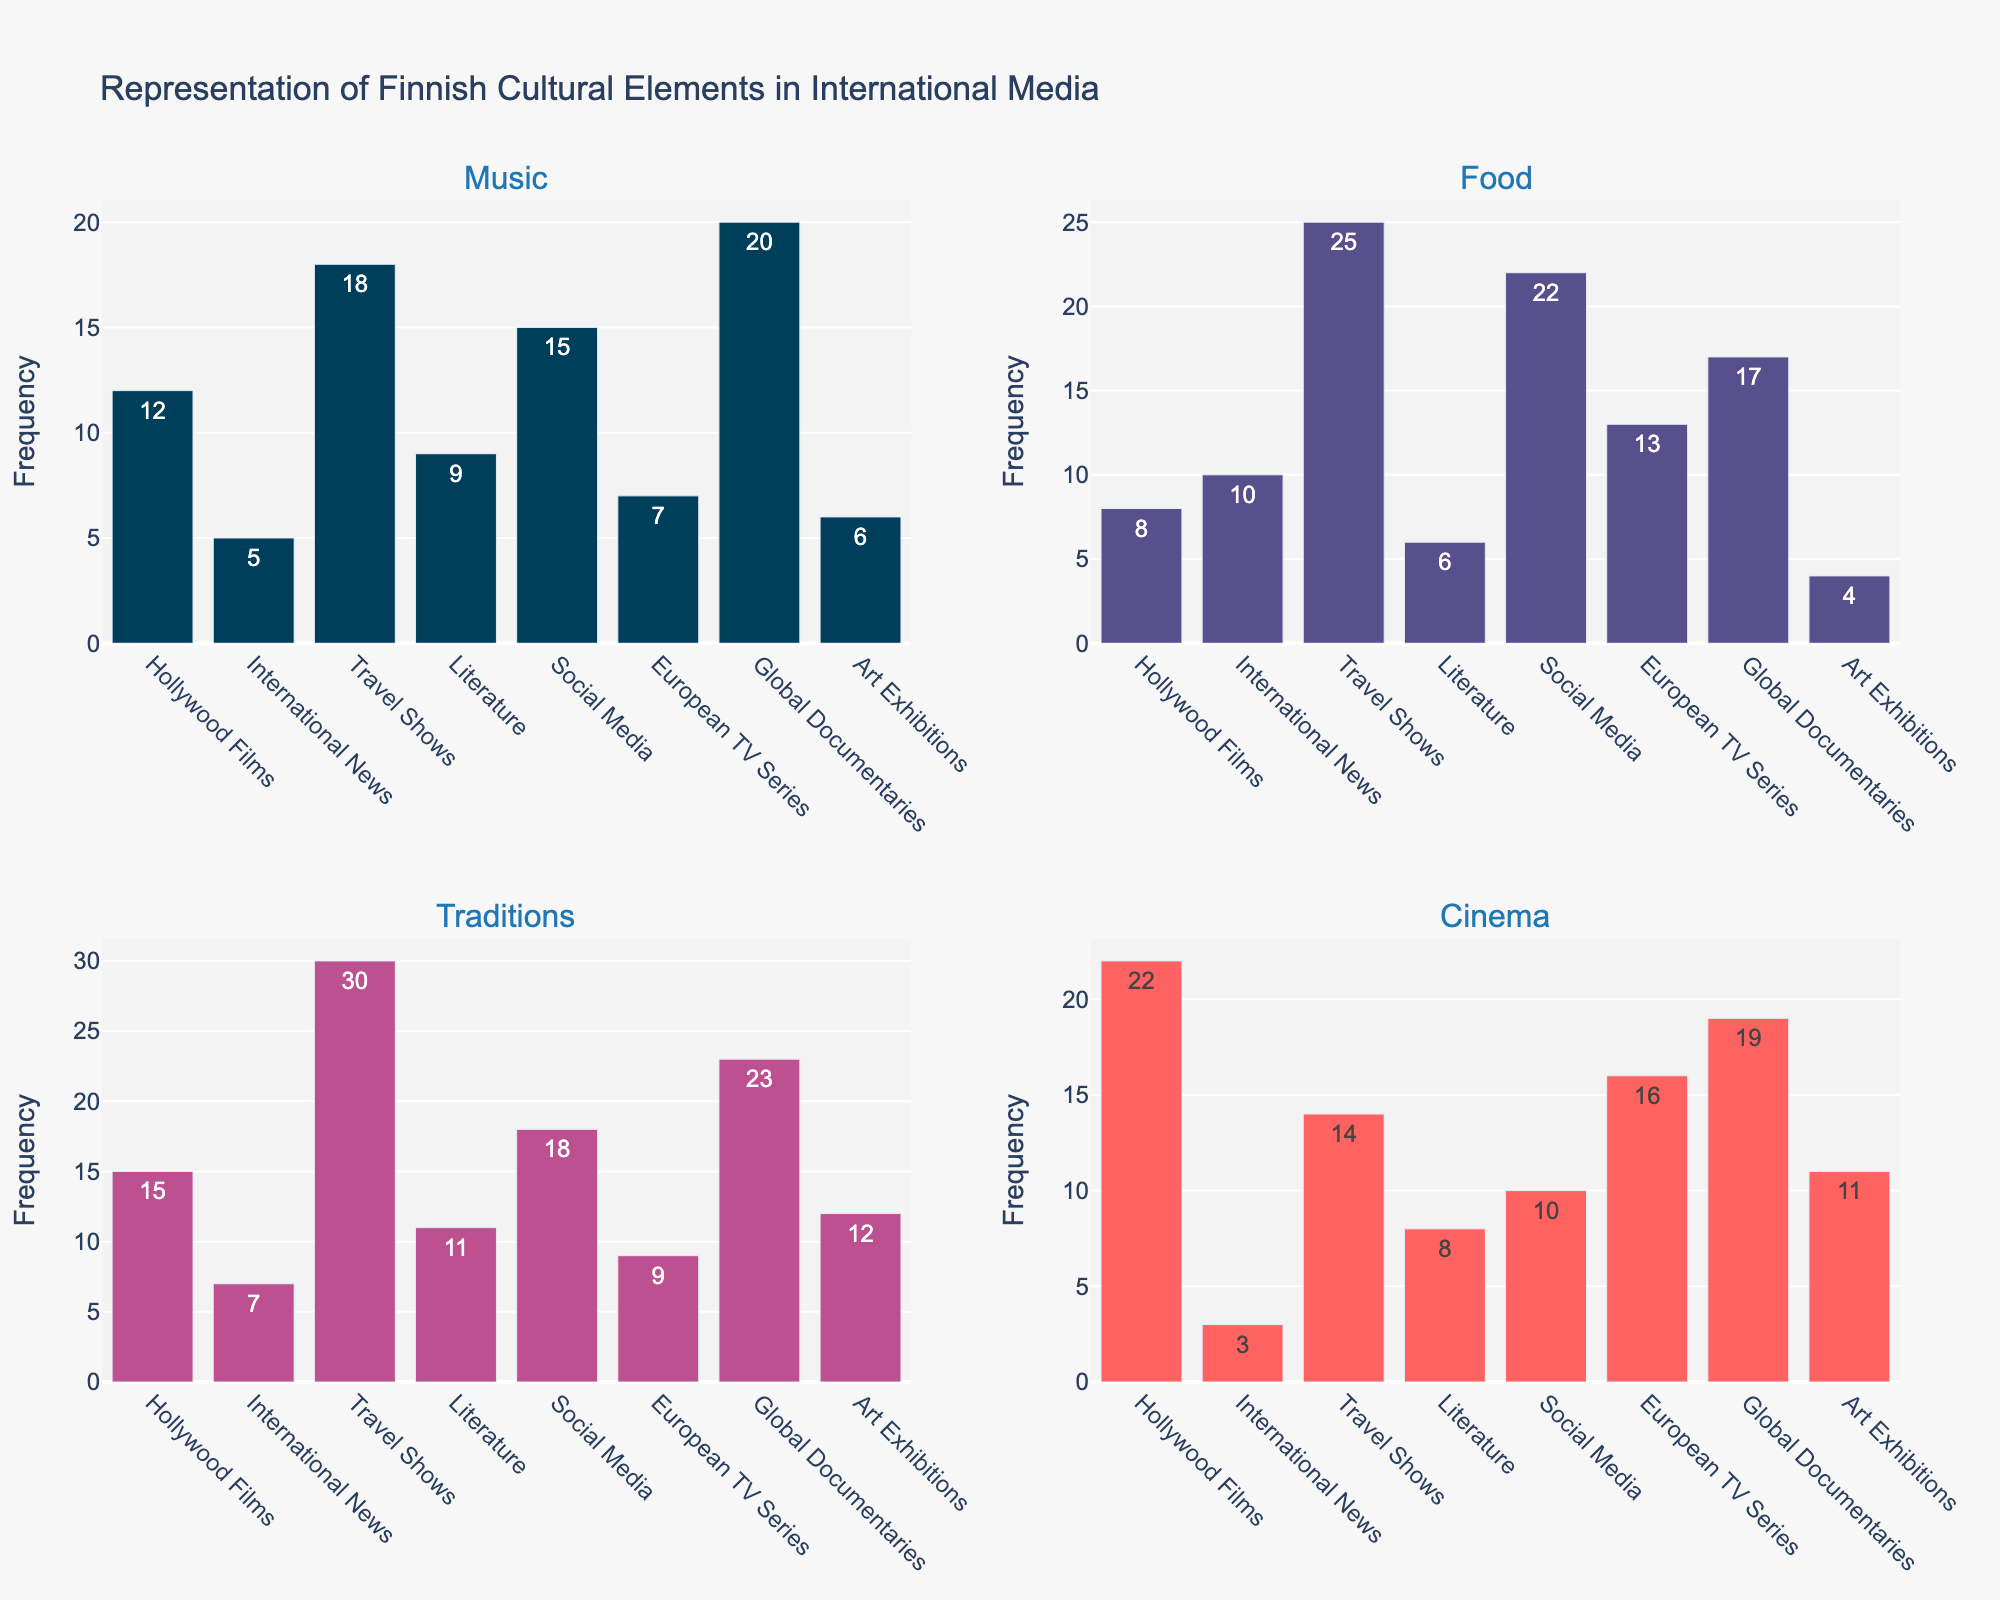What is the total number of representations of Finnish food in international media? Sum the values for Finnish food across all the subplots. (8+10+25+6+22+13+17+4) = 105
Answer: 105 Which category represents Finnish traditions the most? Identify the bar with the highest value in the "Traditions" subplot. The highest value is 30 in Travel Shows.
Answer: Travel Shows In the 'Music' subplot, which category has the lowest representation? Identify the bar with the lowest value in the "Music" subplot. The lowest value is 5 in International News.
Answer: International News How many more representations of Finnish music are in Global Documentaries compared to Hollywood Films? Subtract the number in Hollywood Films from the number in Global Documentaries for the "Music" category. 20 - 12 = 8
Answer: 8 What is the average representation of Finnish cinema across all categories? Sum the values for Finnish cinema and divide by the number of categories. (22+3+14+8+10+16+19+11)/8 = 103/8 = 12.875
Answer: 12.875 Which subplot has the most balanced representation across all categories, meaning the smallest range between the highest and lowest values? Calculate the range (max - min) for each subplot and identify the smallest range. Food: 25-4=21, Music: 20-5=15, Traditions: 30-9=21, Cinema: 22-3=19. Music has the smallest range of 15.
Answer: Music How many representations of Finnish traditions are found in Art Exhibitions and Social Media combined? Sum the values for Finnish traditions in Art Exhibitions and Social Media categories. 12 + 18 = 30
Answer: 30 Which category has the highest representation of Finnish cultural elements in social media? Identify the highest bar in the "Social Media" subplot. The highest value is 22 in Food.
Answer: Food What is the difference in the number of representations of Finnish cinema between Travel Shows and Hollywood Films? Subtract the value of Hollywood Films from the value of Travel Shows for the Cinema category. 14 - 22 = -8
Answer: -8 If you combine all media categories, what would be the combined total representation of Finnish music? Sum the values for Finnish music across all categories. (12+5+18+9+15+7+20+6) = 92
Answer: 92 